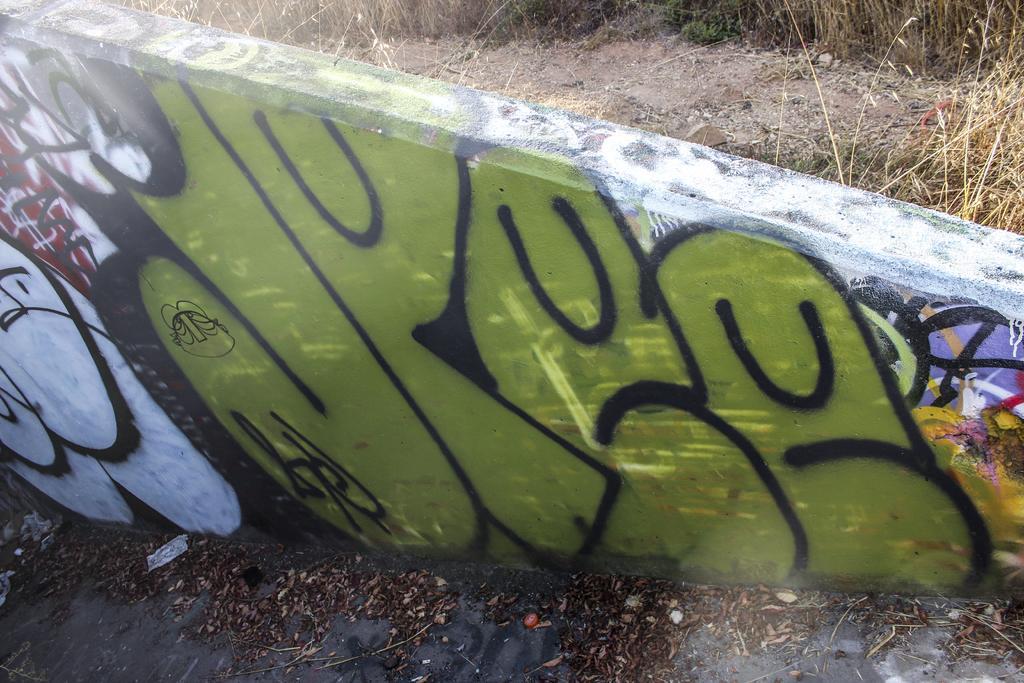Please provide a concise description of this image. There is a painting on a wall in the center of the image and there is dry grass in the background are and there is sand and dry leaves at the bottom side. 